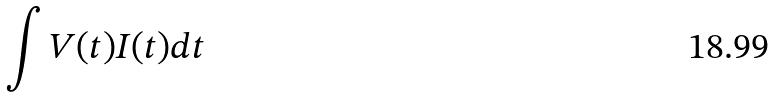Convert formula to latex. <formula><loc_0><loc_0><loc_500><loc_500>\int V ( t ) I ( t ) d t</formula> 